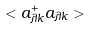Convert formula to latex. <formula><loc_0><loc_0><loc_500><loc_500>< a _ { \lambda k } ^ { + } a _ { \lambda k } ></formula> 